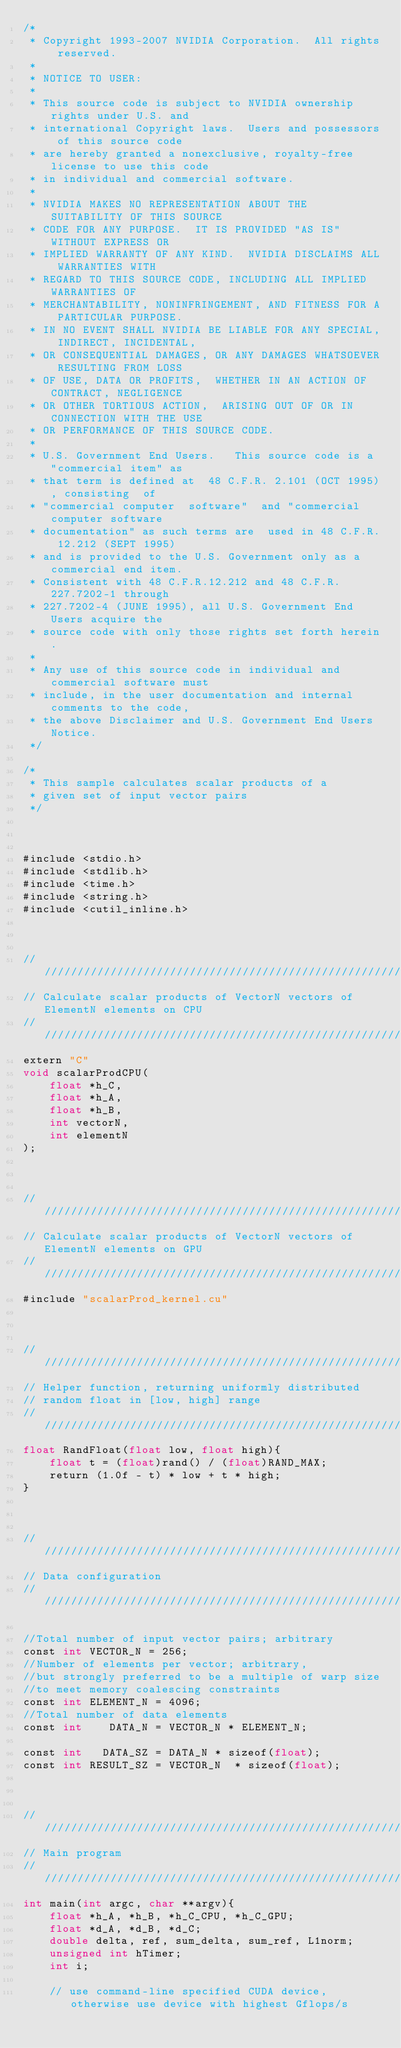Convert code to text. <code><loc_0><loc_0><loc_500><loc_500><_Cuda_>/*
 * Copyright 1993-2007 NVIDIA Corporation.  All rights reserved.
 *
 * NOTICE TO USER:
 *
 * This source code is subject to NVIDIA ownership rights under U.S. and
 * international Copyright laws.  Users and possessors of this source code
 * are hereby granted a nonexclusive, royalty-free license to use this code
 * in individual and commercial software.
 *
 * NVIDIA MAKES NO REPRESENTATION ABOUT THE SUITABILITY OF THIS SOURCE
 * CODE FOR ANY PURPOSE.  IT IS PROVIDED "AS IS" WITHOUT EXPRESS OR
 * IMPLIED WARRANTY OF ANY KIND.  NVIDIA DISCLAIMS ALL WARRANTIES WITH
 * REGARD TO THIS SOURCE CODE, INCLUDING ALL IMPLIED WARRANTIES OF
 * MERCHANTABILITY, NONINFRINGEMENT, AND FITNESS FOR A PARTICULAR PURPOSE.
 * IN NO EVENT SHALL NVIDIA BE LIABLE FOR ANY SPECIAL, INDIRECT, INCIDENTAL,
 * OR CONSEQUENTIAL DAMAGES, OR ANY DAMAGES WHATSOEVER RESULTING FROM LOSS
 * OF USE, DATA OR PROFITS,  WHETHER IN AN ACTION OF CONTRACT, NEGLIGENCE
 * OR OTHER TORTIOUS ACTION,  ARISING OUT OF OR IN CONNECTION WITH THE USE
 * OR PERFORMANCE OF THIS SOURCE CODE.
 *
 * U.S. Government End Users.   This source code is a "commercial item" as
 * that term is defined at  48 C.F.R. 2.101 (OCT 1995), consisting  of
 * "commercial computer  software"  and "commercial computer software
 * documentation" as such terms are  used in 48 C.F.R. 12.212 (SEPT 1995)
 * and is provided to the U.S. Government only as a commercial end item.
 * Consistent with 48 C.F.R.12.212 and 48 C.F.R. 227.7202-1 through
 * 227.7202-4 (JUNE 1995), all U.S. Government End Users acquire the
 * source code with only those rights set forth herein.
 *
 * Any use of this source code in individual and commercial software must
 * include, in the user documentation and internal comments to the code,
 * the above Disclaimer and U.S. Government End Users Notice.
 */

/*
 * This sample calculates scalar products of a 
 * given set of input vector pairs
 */



#include <stdio.h>
#include <stdlib.h>
#include <time.h>
#include <string.h>
#include <cutil_inline.h>



///////////////////////////////////////////////////////////////////////////////
// Calculate scalar products of VectorN vectors of ElementN elements on CPU
///////////////////////////////////////////////////////////////////////////////
extern "C"
void scalarProdCPU(
    float *h_C,
    float *h_A,
    float *h_B,
    int vectorN,
    int elementN
);



///////////////////////////////////////////////////////////////////////////////
// Calculate scalar products of VectorN vectors of ElementN elements on GPU
///////////////////////////////////////////////////////////////////////////////
#include "scalarProd_kernel.cu"



////////////////////////////////////////////////////////////////////////////////
// Helper function, returning uniformly distributed
// random float in [low, high] range
////////////////////////////////////////////////////////////////////////////////
float RandFloat(float low, float high){
    float t = (float)rand() / (float)RAND_MAX;
    return (1.0f - t) * low + t * high;
}



///////////////////////////////////////////////////////////////////////////////
// Data configuration
///////////////////////////////////////////////////////////////////////////////

//Total number of input vector pairs; arbitrary
const int VECTOR_N = 256;
//Number of elements per vector; arbitrary, 
//but strongly preferred to be a multiple of warp size
//to meet memory coalescing constraints
const int ELEMENT_N = 4096;
//Total number of data elements
const int    DATA_N = VECTOR_N * ELEMENT_N;

const int   DATA_SZ = DATA_N * sizeof(float);
const int RESULT_SZ = VECTOR_N  * sizeof(float);



///////////////////////////////////////////////////////////////////////////////
// Main program
///////////////////////////////////////////////////////////////////////////////
int main(int argc, char **argv){
    float *h_A, *h_B, *h_C_CPU, *h_C_GPU;
    float *d_A, *d_B, *d_C;
    double delta, ref, sum_delta, sum_ref, L1norm;
    unsigned int hTimer;
    int i;

    // use command-line specified CUDA device, otherwise use device with highest Gflops/s</code> 